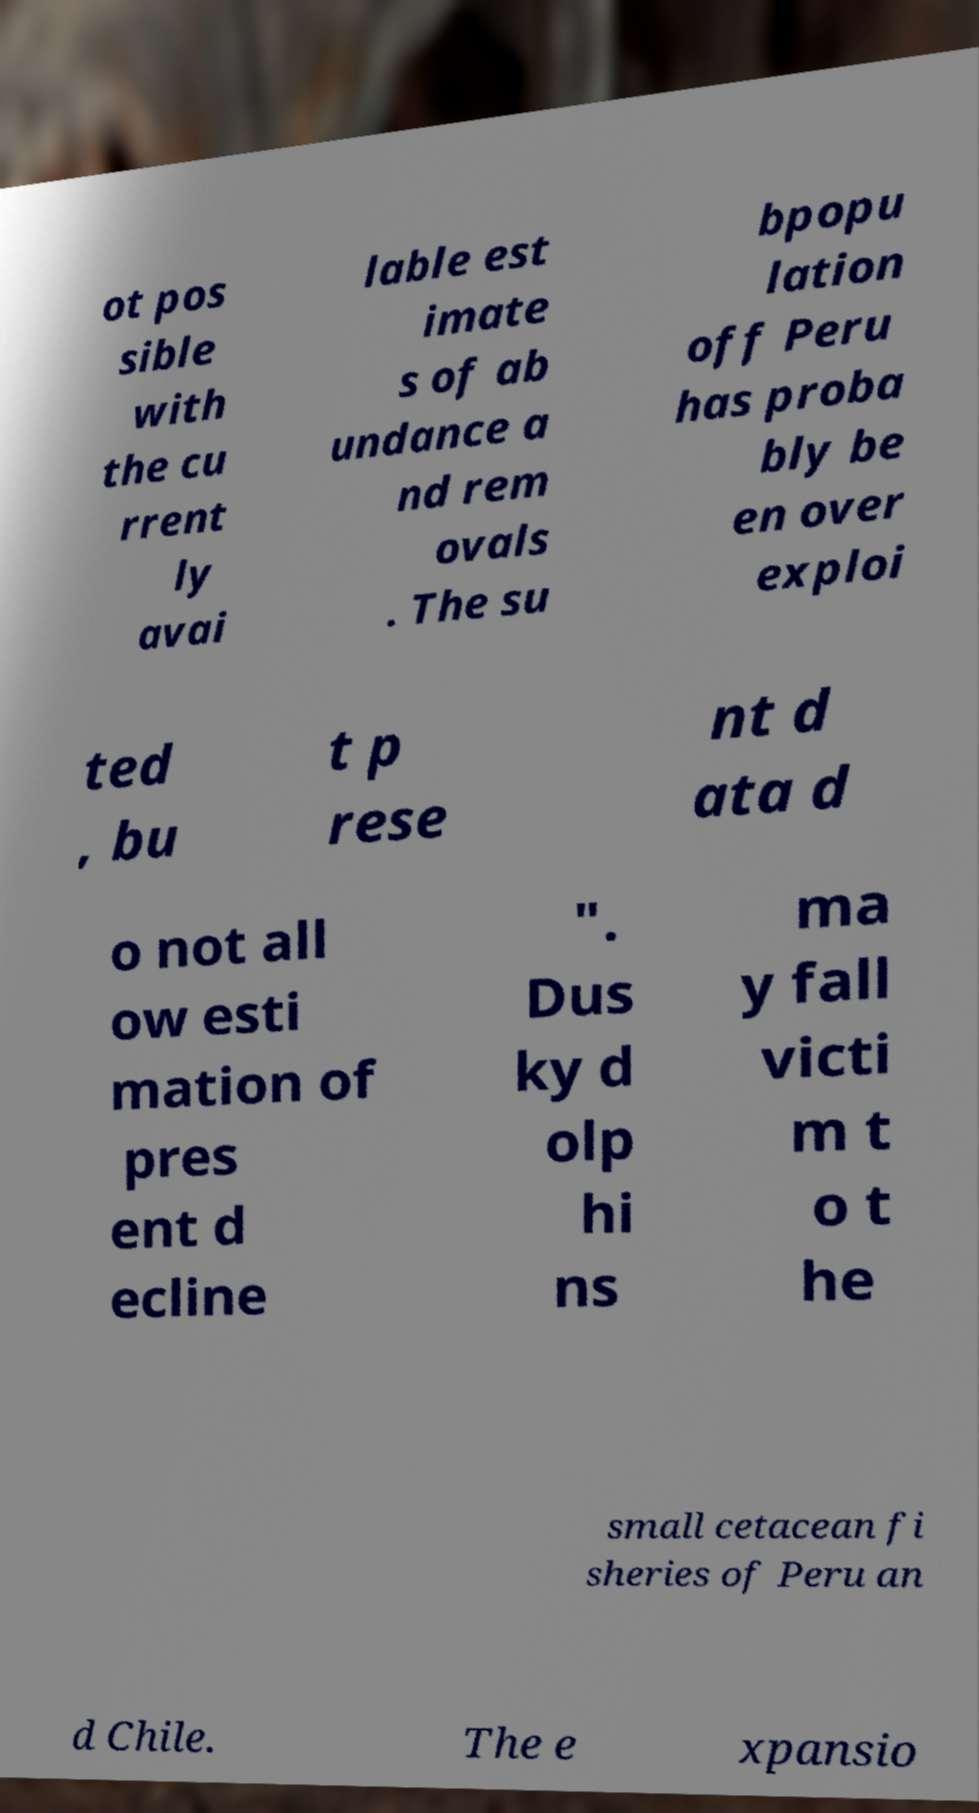Please identify and transcribe the text found in this image. ot pos sible with the cu rrent ly avai lable est imate s of ab undance a nd rem ovals . The su bpopu lation off Peru has proba bly be en over exploi ted , bu t p rese nt d ata d o not all ow esti mation of pres ent d ecline ". Dus ky d olp hi ns ma y fall victi m t o t he small cetacean fi sheries of Peru an d Chile. The e xpansio 